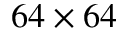Convert formula to latex. <formula><loc_0><loc_0><loc_500><loc_500>6 4 \times 6 4</formula> 